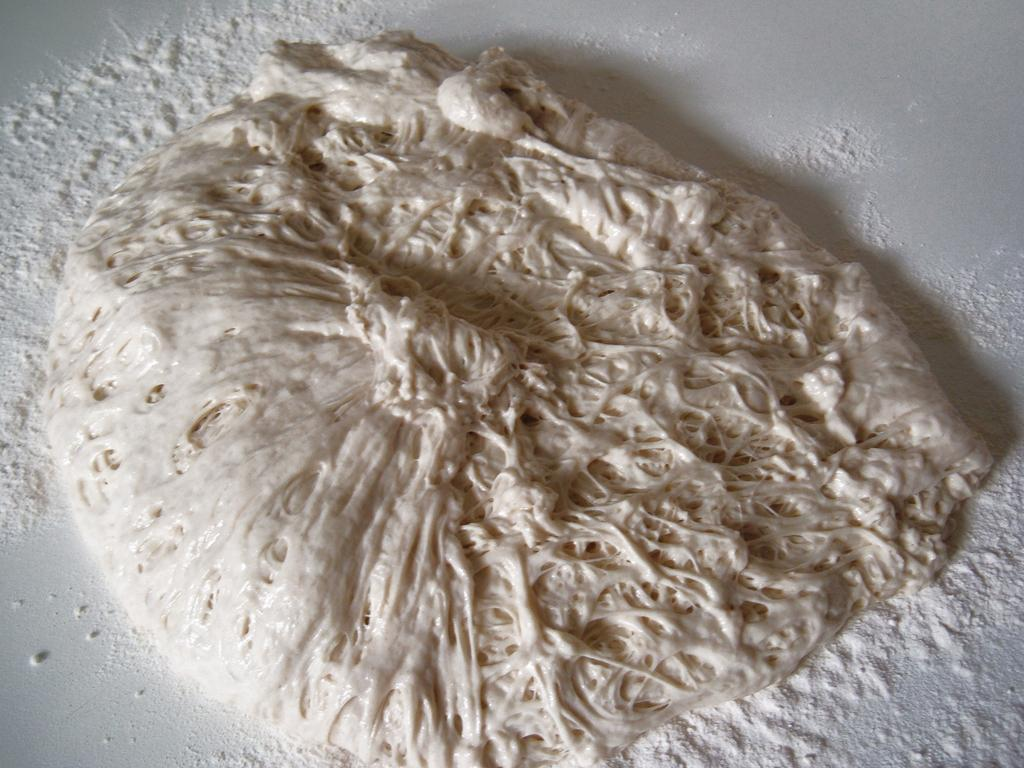What is the color of the surface in the image? The surface in the image is white. What can be seen on the white surface? There is white powder and a white, semi-solid substance on the surface. What type of building is visible in the image? There is no building present in the image; it only features a white surface with white powder and a white, semi-solid substance. What type of liquid can be seen in the image? There is no liquid present in the image; it only features a white surface with white powder and a white, semi-solid substance. 